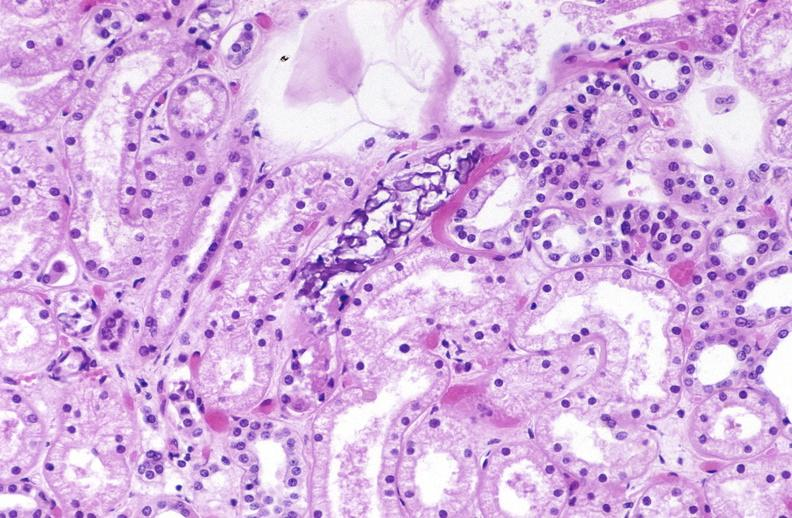does this image show atn and calcium deposits?
Answer the question using a single word or phrase. Yes 